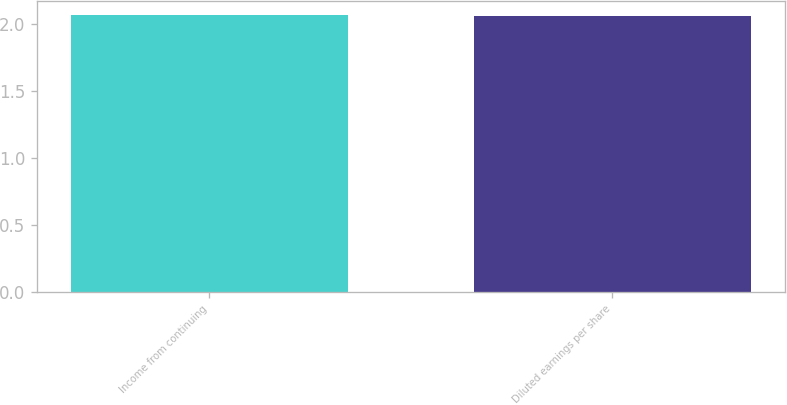Convert chart. <chart><loc_0><loc_0><loc_500><loc_500><bar_chart><fcel>Income from continuing<fcel>Diluted earnings per share<nl><fcel>2.07<fcel>2.06<nl></chart> 